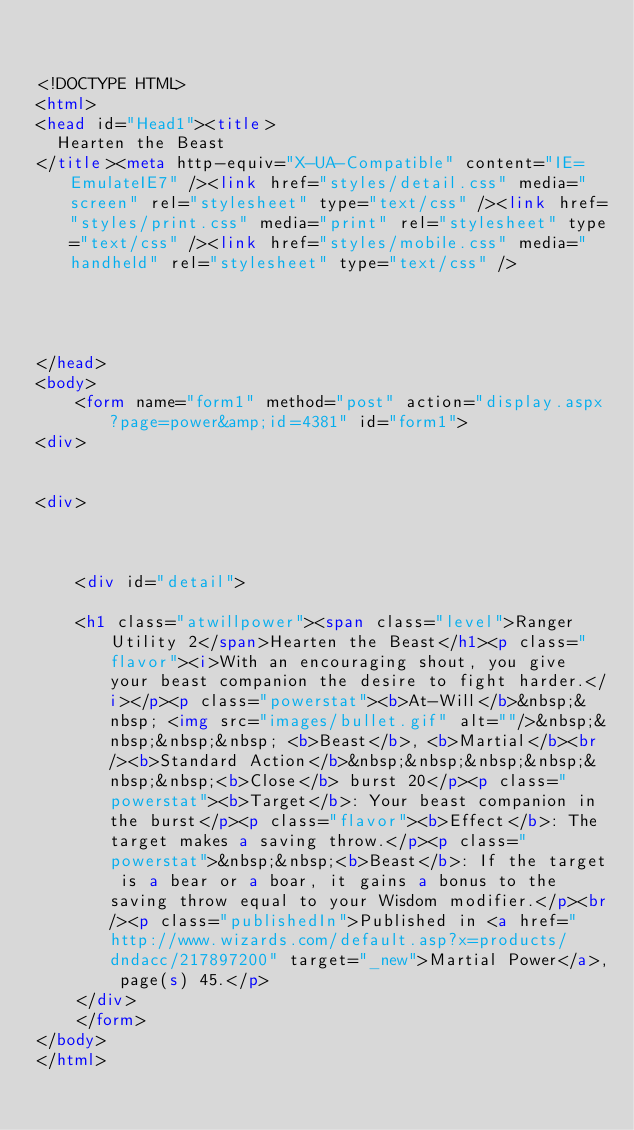Convert code to text. <code><loc_0><loc_0><loc_500><loc_500><_HTML_>

<!DOCTYPE HTML>
<html>
<head id="Head1"><title>
	Hearten the Beast
</title><meta http-equiv="X-UA-Compatible" content="IE=EmulateIE7" /><link href="styles/detail.css" media="screen" rel="stylesheet" type="text/css" /><link href="styles/print.css" media="print" rel="stylesheet" type="text/css" /><link href="styles/mobile.css" media="handheld" rel="stylesheet" type="text/css" />
    
    
    

</head>
<body>
    <form name="form1" method="post" action="display.aspx?page=power&amp;id=4381" id="form1">
<div>


<div>

	
	
    <div id="detail">
		
		<h1 class="atwillpower"><span class="level">Ranger Utility 2</span>Hearten the Beast</h1><p class="flavor"><i>With an encouraging shout, you give your beast companion the desire to fight harder.</i></p><p class="powerstat"><b>At-Will</b>&nbsp;&nbsp; <img src="images/bullet.gif" alt=""/>&nbsp;&nbsp;&nbsp;&nbsp; <b>Beast</b>, <b>Martial</b><br/><b>Standard Action</b>&nbsp;&nbsp;&nbsp;&nbsp;&nbsp;&nbsp;<b>Close</b> burst 20</p><p class="powerstat"><b>Target</b>: Your beast companion in the burst</p><p class="flavor"><b>Effect</b>: The target makes a saving throw.</p><p class="powerstat">&nbsp;&nbsp;<b>Beast</b>: If the target is a bear or a boar, it gains a bonus to the saving throw equal to your Wisdom modifier.</p><br/><p class="publishedIn">Published in <a href="http://www.wizards.com/default.asp?x=products/dndacc/217897200" target="_new">Martial Power</a>, page(s) 45.</p>
    </div>
    </form>
</body>
</html>


</code> 